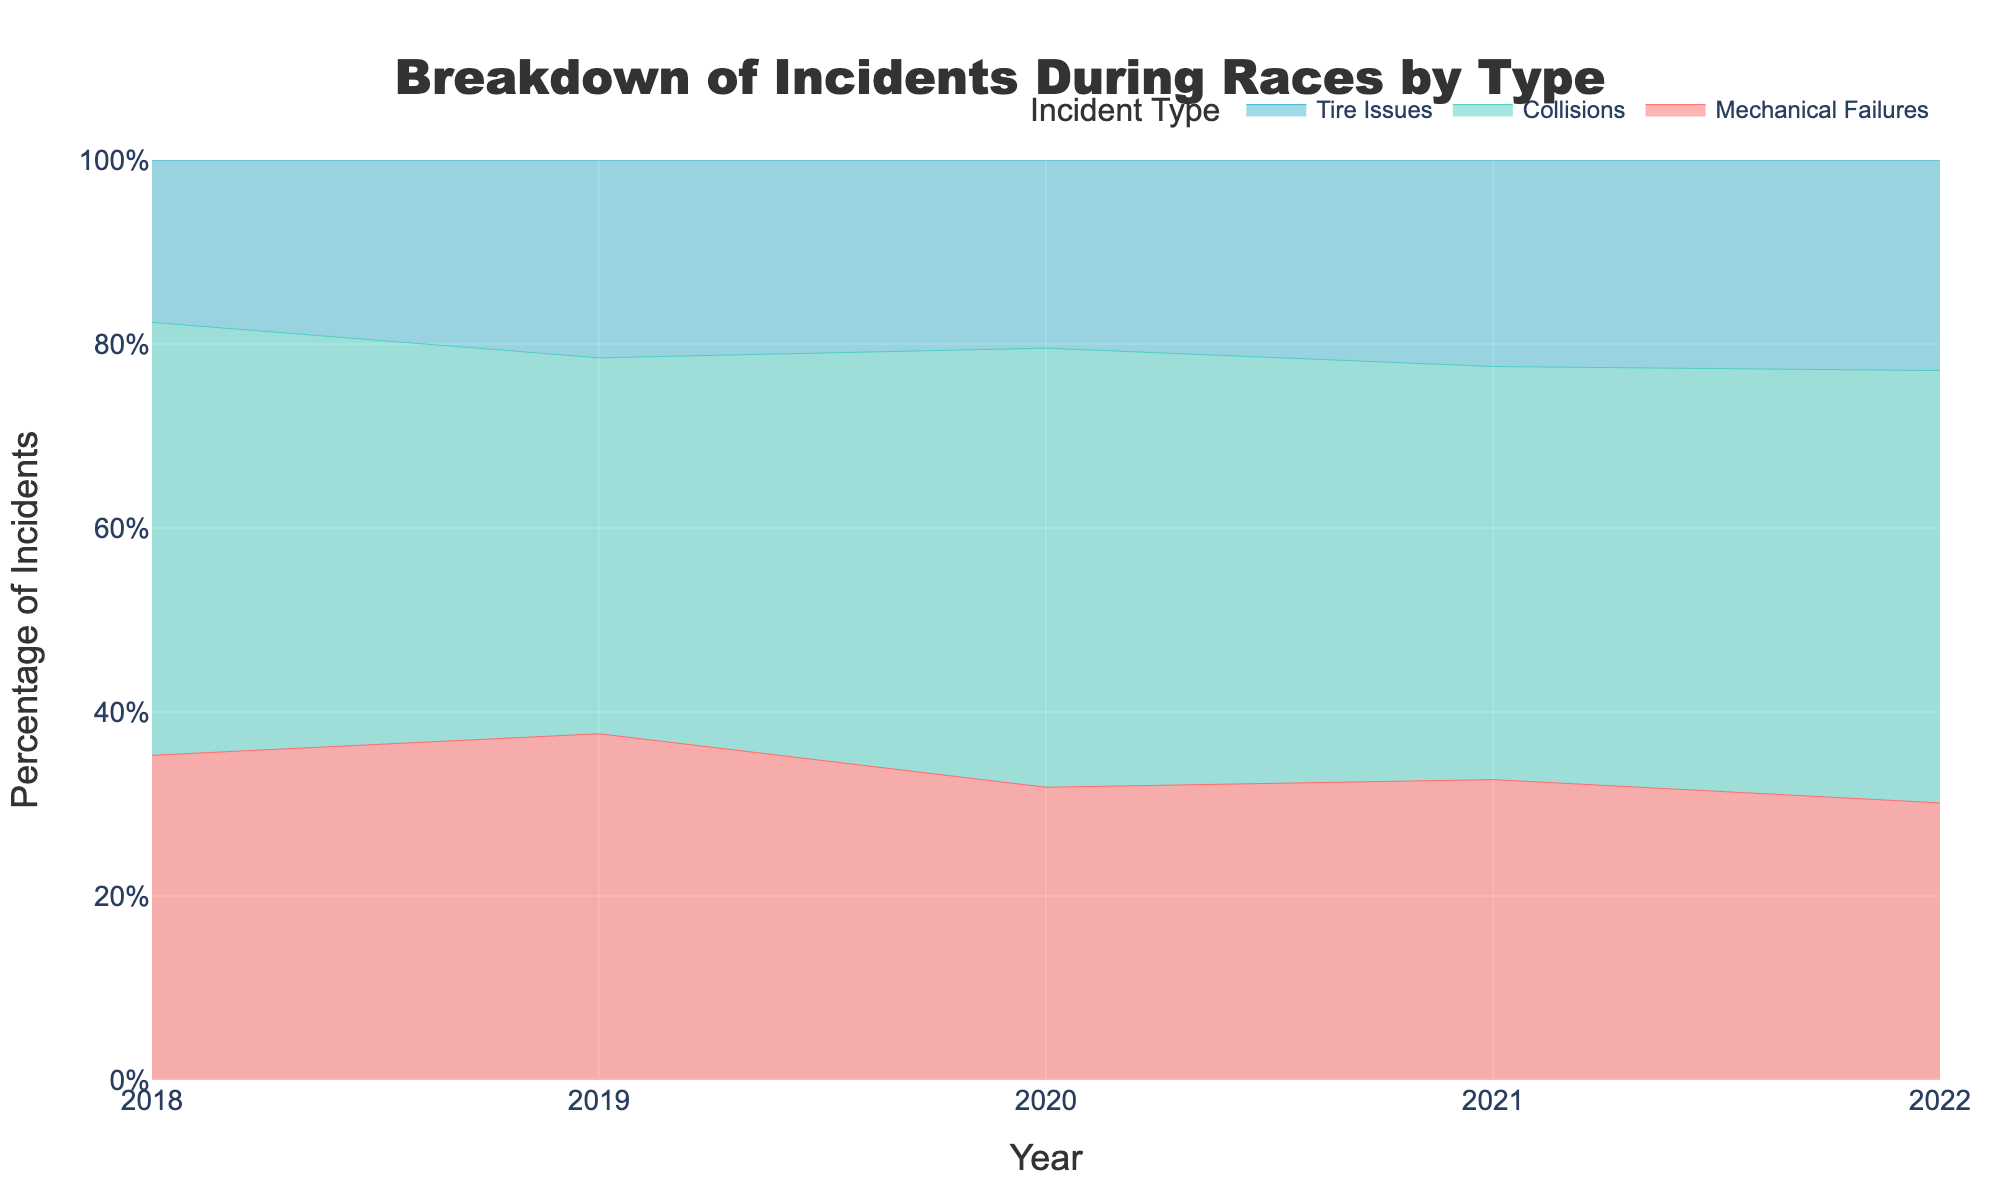What is the title of the chart? The title of the chart is often located at the top and provides a summary of what the chart represents. In this case, it reads "Breakdown of Incidents During Races by Type."
Answer: Breakdown of Incidents During Races by Type What are the three types of incidents displayed in the chart? The types of incidents are distinguished by color and are labeled in the legend of the chart. They are Mechanical Failures, Collisions, and Tire Issues.
Answer: Mechanical Failures, Collisions, Tire Issues How did the percentage of Mechanical Failures change from 2018 to 2022? In 2018, Mechanical Failures accounted for approximately 30%. In 2022, they accounted for approximately 25%. By subtracting the latter from the former, we see a decrease.
Answer: Decreased by approximately 5% Which year had the highest percentage of Tire Issues? To find the highest percentage, we look at the chart and compare the segments representing Tire Issues (light blue segment) across the years. The highest point appears to be in 2021.
Answer: 2021 What is the trend for Collisions from 2018 to 2022? Looking at the area covered by the section for Collisions (green segment), it appears the percentage slightly increased from 2018 (~40%) to 2021 (~44%), then slightly decreased by 2022 (~39%).
Answer: Increased then slightly decreased In which year did Mechanical Failures have the lowest percentage? By comparing the sections of the chart corresponding to Mechanical Failures (red segment) across all years, the smallest section is in 2022.
Answer: 2022 How does the proportion of Collisions in 2020 compare to that in 2019? In 2019, Collisions made up approximately 38% of incidents. In 2020, this increased to approximately 42%. Hence, there was an increase.
Answer: Increased by approximately 4% Which type of incident remained relatively stable over the years? By examining the chart for a segment that does not show much variation in area, Tire Issues (light blue) appear to have relatively small fluctuations compared to others.
Answer: Tire Issues Are there any years where Mechanical Failures accounted for the majority of incidents? To be the majority, Mechanical Failures would need more than 50%. Upon reviewing each year, there is no year where this segment exceeds 50%.
Answer: No Calculate the average percentage of Tire Issues over the given years. The percentages of Tire Issues are approximately 15% (2018), 20% (2019), 18% (2020), 22% (2021), and 19% (2022). Summing these, we get 94%. Dividing by 5 years gives an average (94/5 = 18.8%).
Answer: 18.8% 